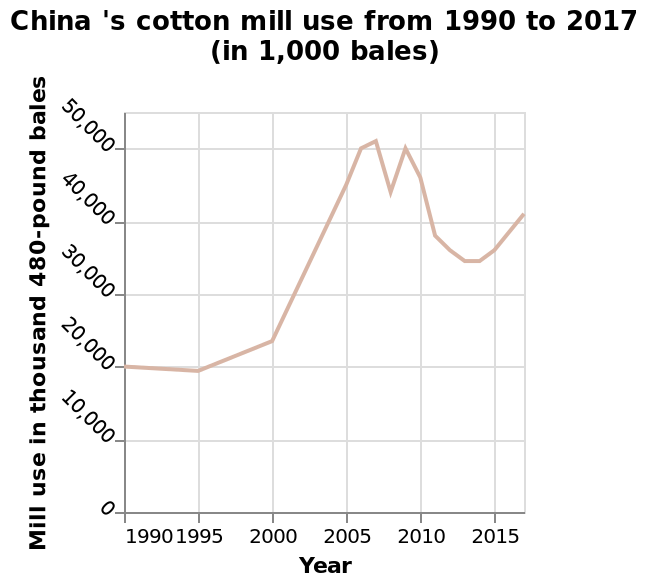<image>
please summary the statistics and relations of the chart In the early years shown on this line chart (1990-1995) production of bales was virtually constant. This was followed by a slight increase and then huge increases until 2005. Apart from a small dip for your year, bale production remained high before falling again from 2010.  What is the minimum value on the y-axis?  The minimum value on the y-axis is 0. When did bale production start to fall? Bale production started to fall again from 2010. 